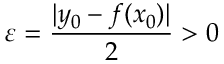<formula> <loc_0><loc_0><loc_500><loc_500>\varepsilon = { \frac { | y _ { 0 } - f ( x _ { 0 } ) | } { 2 } } > 0</formula> 